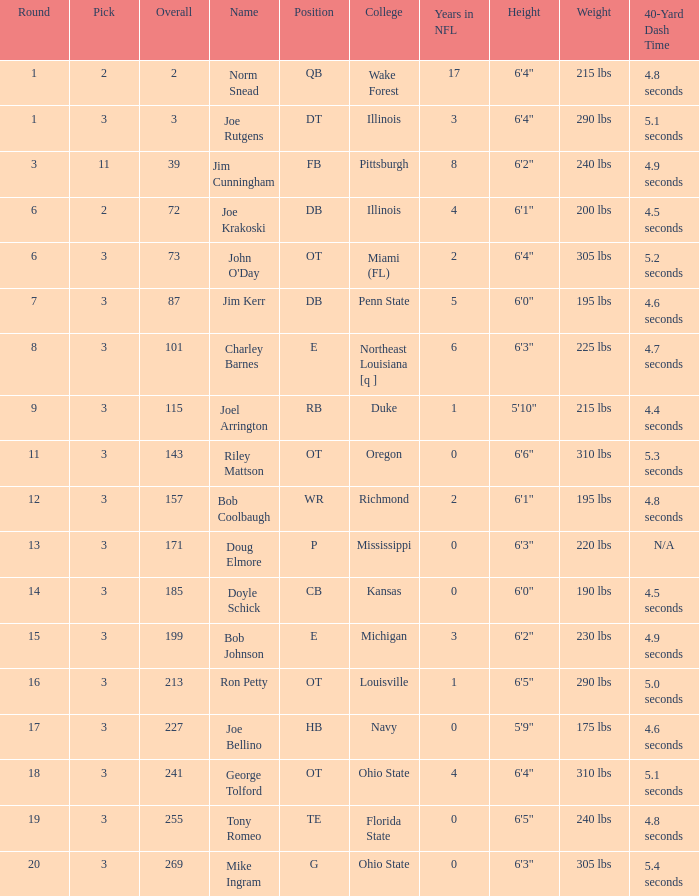How many rounds have john o'day as the name, and a pick less than 3? None. 